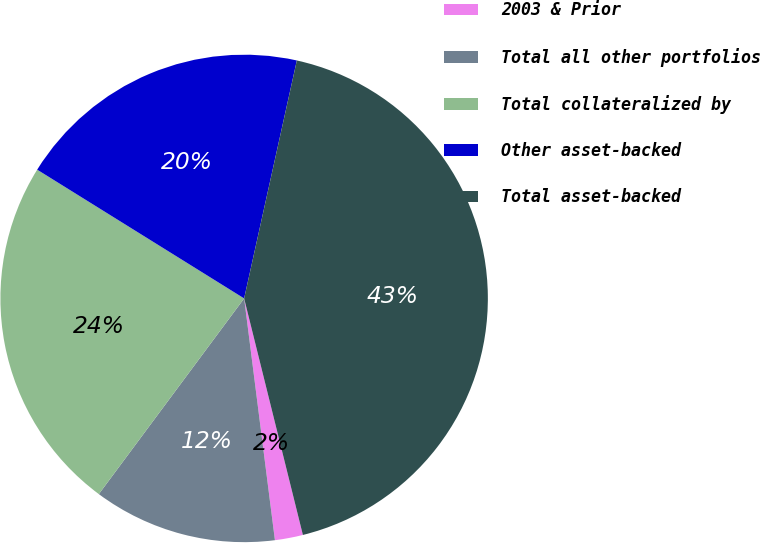Convert chart. <chart><loc_0><loc_0><loc_500><loc_500><pie_chart><fcel>2003 & Prior<fcel>Total all other portfolios<fcel>Total collateralized by<fcel>Other asset-backed<fcel>Total asset-backed<nl><fcel>1.86%<fcel>12.18%<fcel>23.69%<fcel>19.61%<fcel>42.65%<nl></chart> 